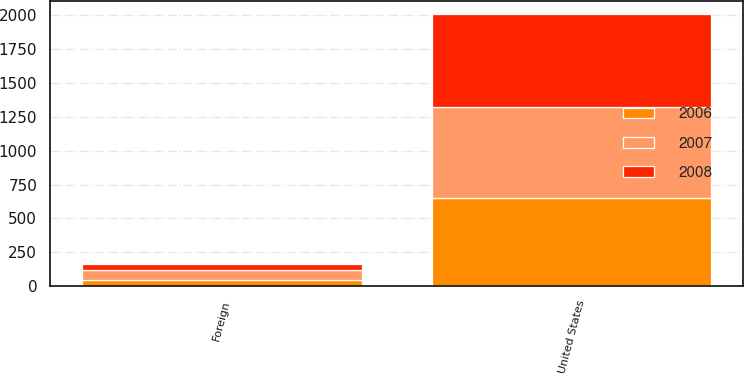<chart> <loc_0><loc_0><loc_500><loc_500><stacked_bar_chart><ecel><fcel>United States<fcel>Foreign<nl><fcel>2007<fcel>676.3<fcel>69.6<nl><fcel>2008<fcel>681.2<fcel>46.6<nl><fcel>2006<fcel>649.8<fcel>48.8<nl></chart> 